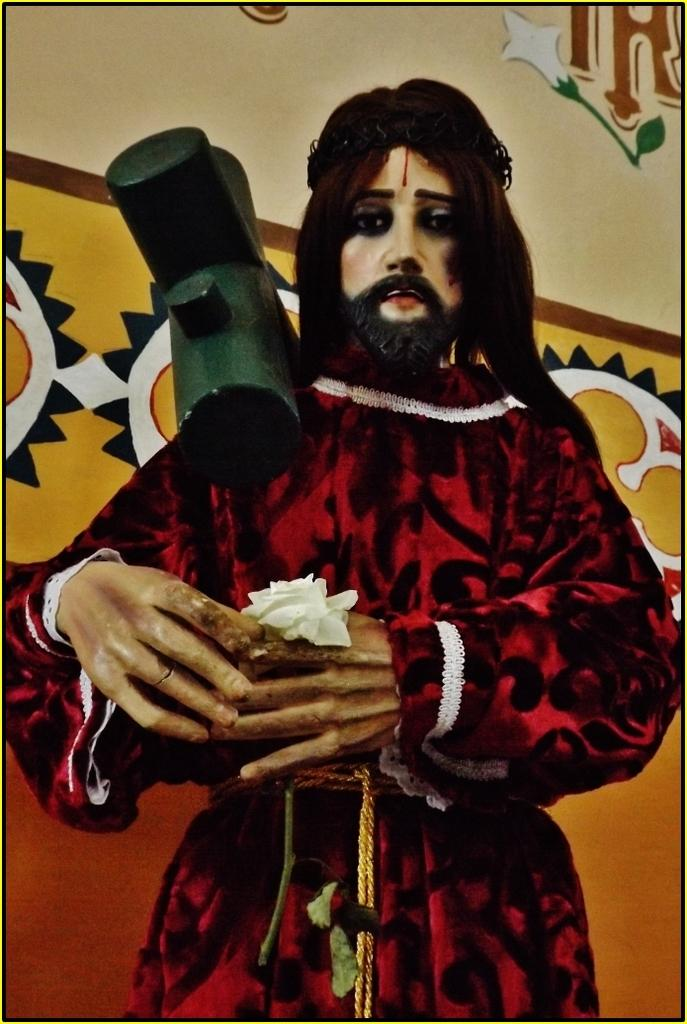What is the main subject of the image? There is a statue of a person in the image. What is the person in the statue holding? The person is holding a flower with a stem. Are there any additional features on the statue? Yes, the statue has a cross on the shoulder. What can be seen in the background of the image? There is a wall with a painting in the background of the image. Can you see the person in the statue taking a flight in the image? There is no indication of a flight or any flying activity in the image; it features a statue of a person holding a flower. 